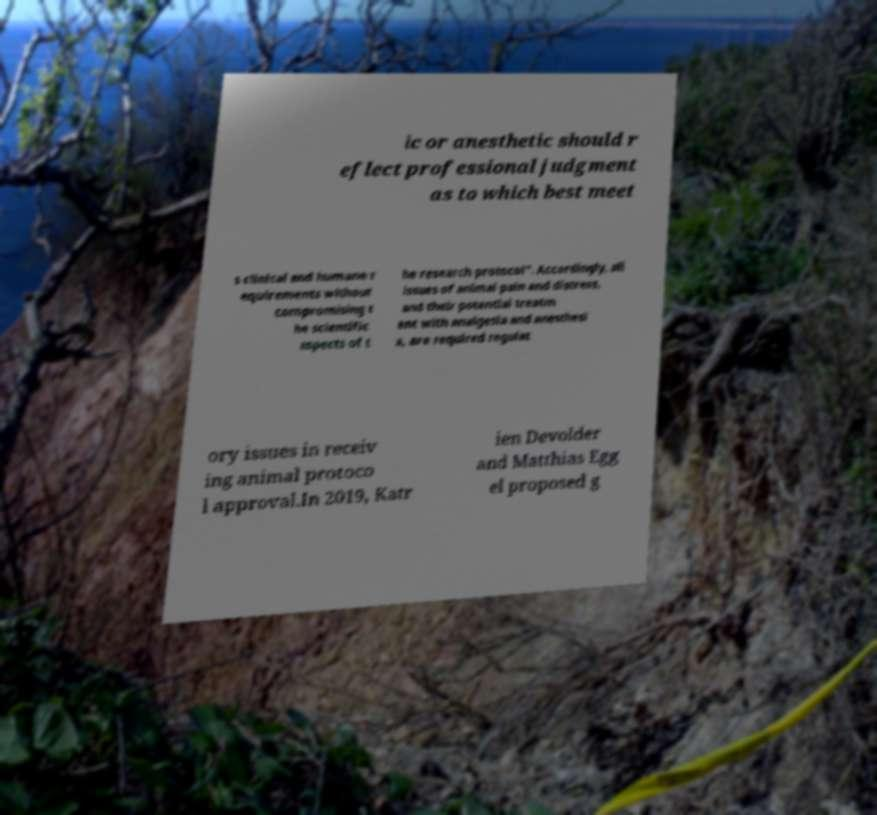For documentation purposes, I need the text within this image transcribed. Could you provide that? ic or anesthetic should r eflect professional judgment as to which best meet s clinical and humane r equirements without compromising t he scientific aspects of t he research protocol". Accordingly, all issues of animal pain and distress, and their potential treatm ent with analgesia and anesthesi a, are required regulat ory issues in receiv ing animal protoco l approval.In 2019, Katr ien Devolder and Matthias Egg el proposed g 